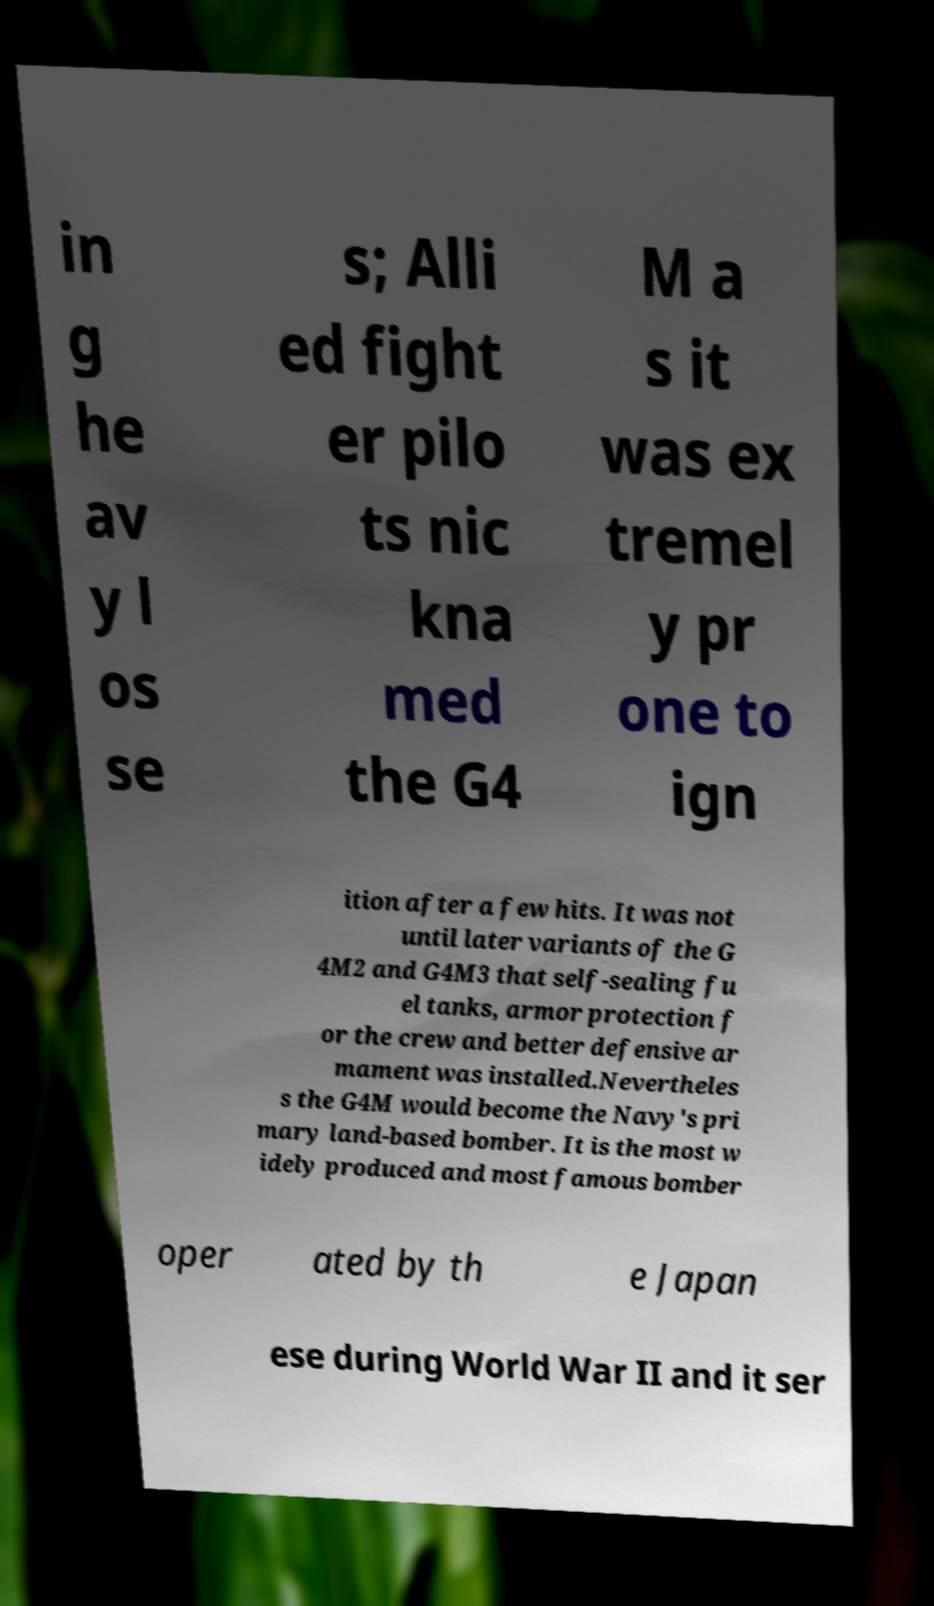What messages or text are displayed in this image? I need them in a readable, typed format. in g he av y l os se s; Alli ed fight er pilo ts nic kna med the G4 M a s it was ex tremel y pr one to ign ition after a few hits. It was not until later variants of the G 4M2 and G4M3 that self-sealing fu el tanks, armor protection f or the crew and better defensive ar mament was installed.Nevertheles s the G4M would become the Navy's pri mary land-based bomber. It is the most w idely produced and most famous bomber oper ated by th e Japan ese during World War II and it ser 